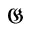Convert formula to latex. <formula><loc_0><loc_0><loc_500><loc_500>\mathfrak { G }</formula> 